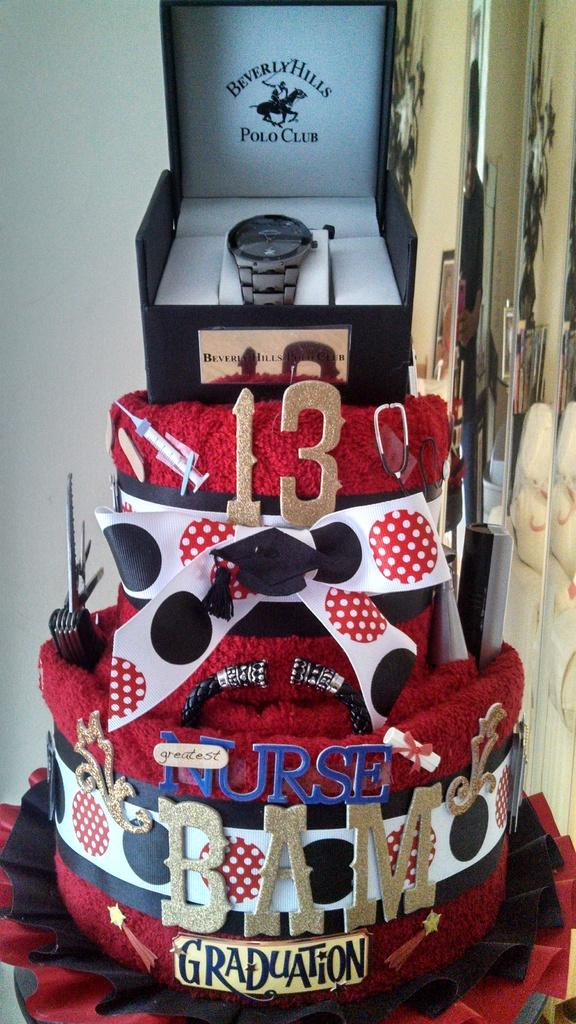<image>
Summarize the visual content of the image. A crafted cake with a Polo wrist watch in a case placed on the top. 